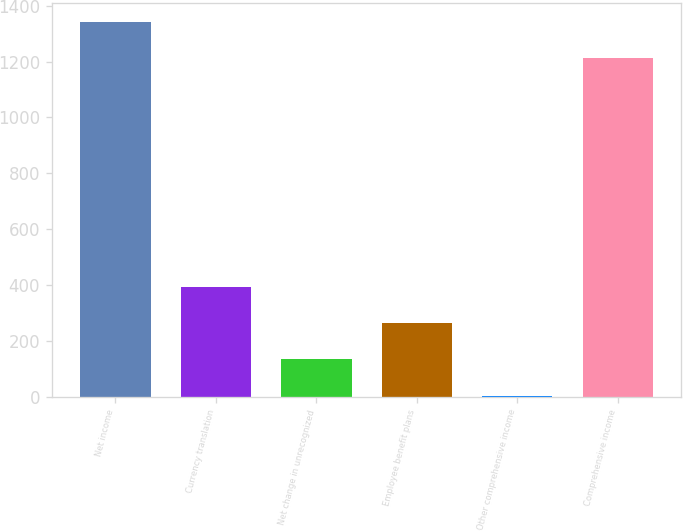<chart> <loc_0><loc_0><loc_500><loc_500><bar_chart><fcel>Net income<fcel>Currency translation<fcel>Net change in unrecognized<fcel>Employee benefit plans<fcel>Other comprehensive income<fcel>Comprehensive income<nl><fcel>1342.1<fcel>394.3<fcel>134.1<fcel>264.2<fcel>4<fcel>1212<nl></chart> 